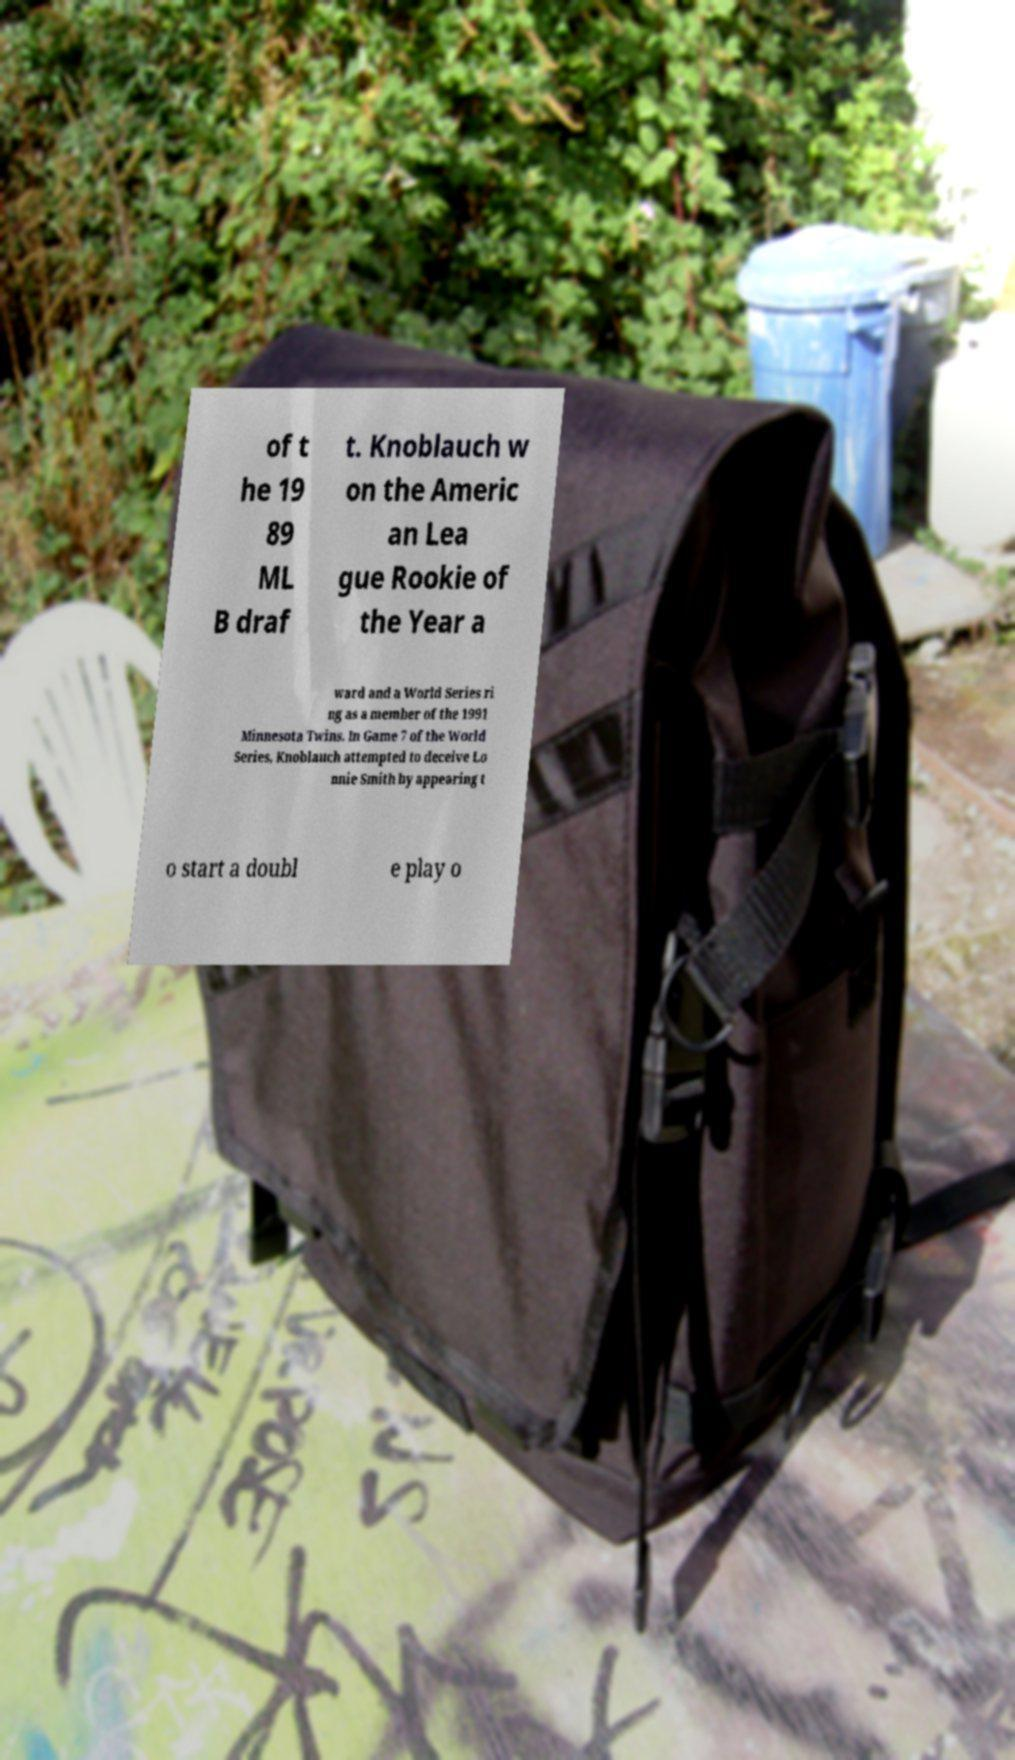Can you accurately transcribe the text from the provided image for me? of t he 19 89 ML B draf t. Knoblauch w on the Americ an Lea gue Rookie of the Year a ward and a World Series ri ng as a member of the 1991 Minnesota Twins. In Game 7 of the World Series, Knoblauch attempted to deceive Lo nnie Smith by appearing t o start a doubl e play o 